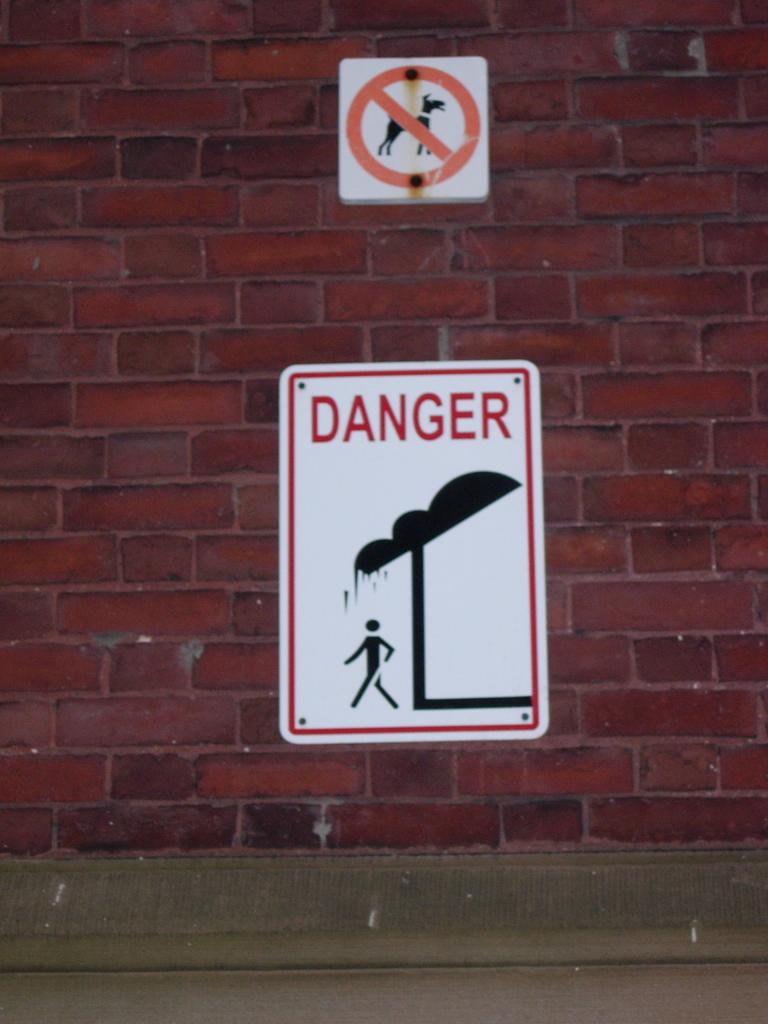Is this a danger sign?
Ensure brevity in your answer.  Yes. 